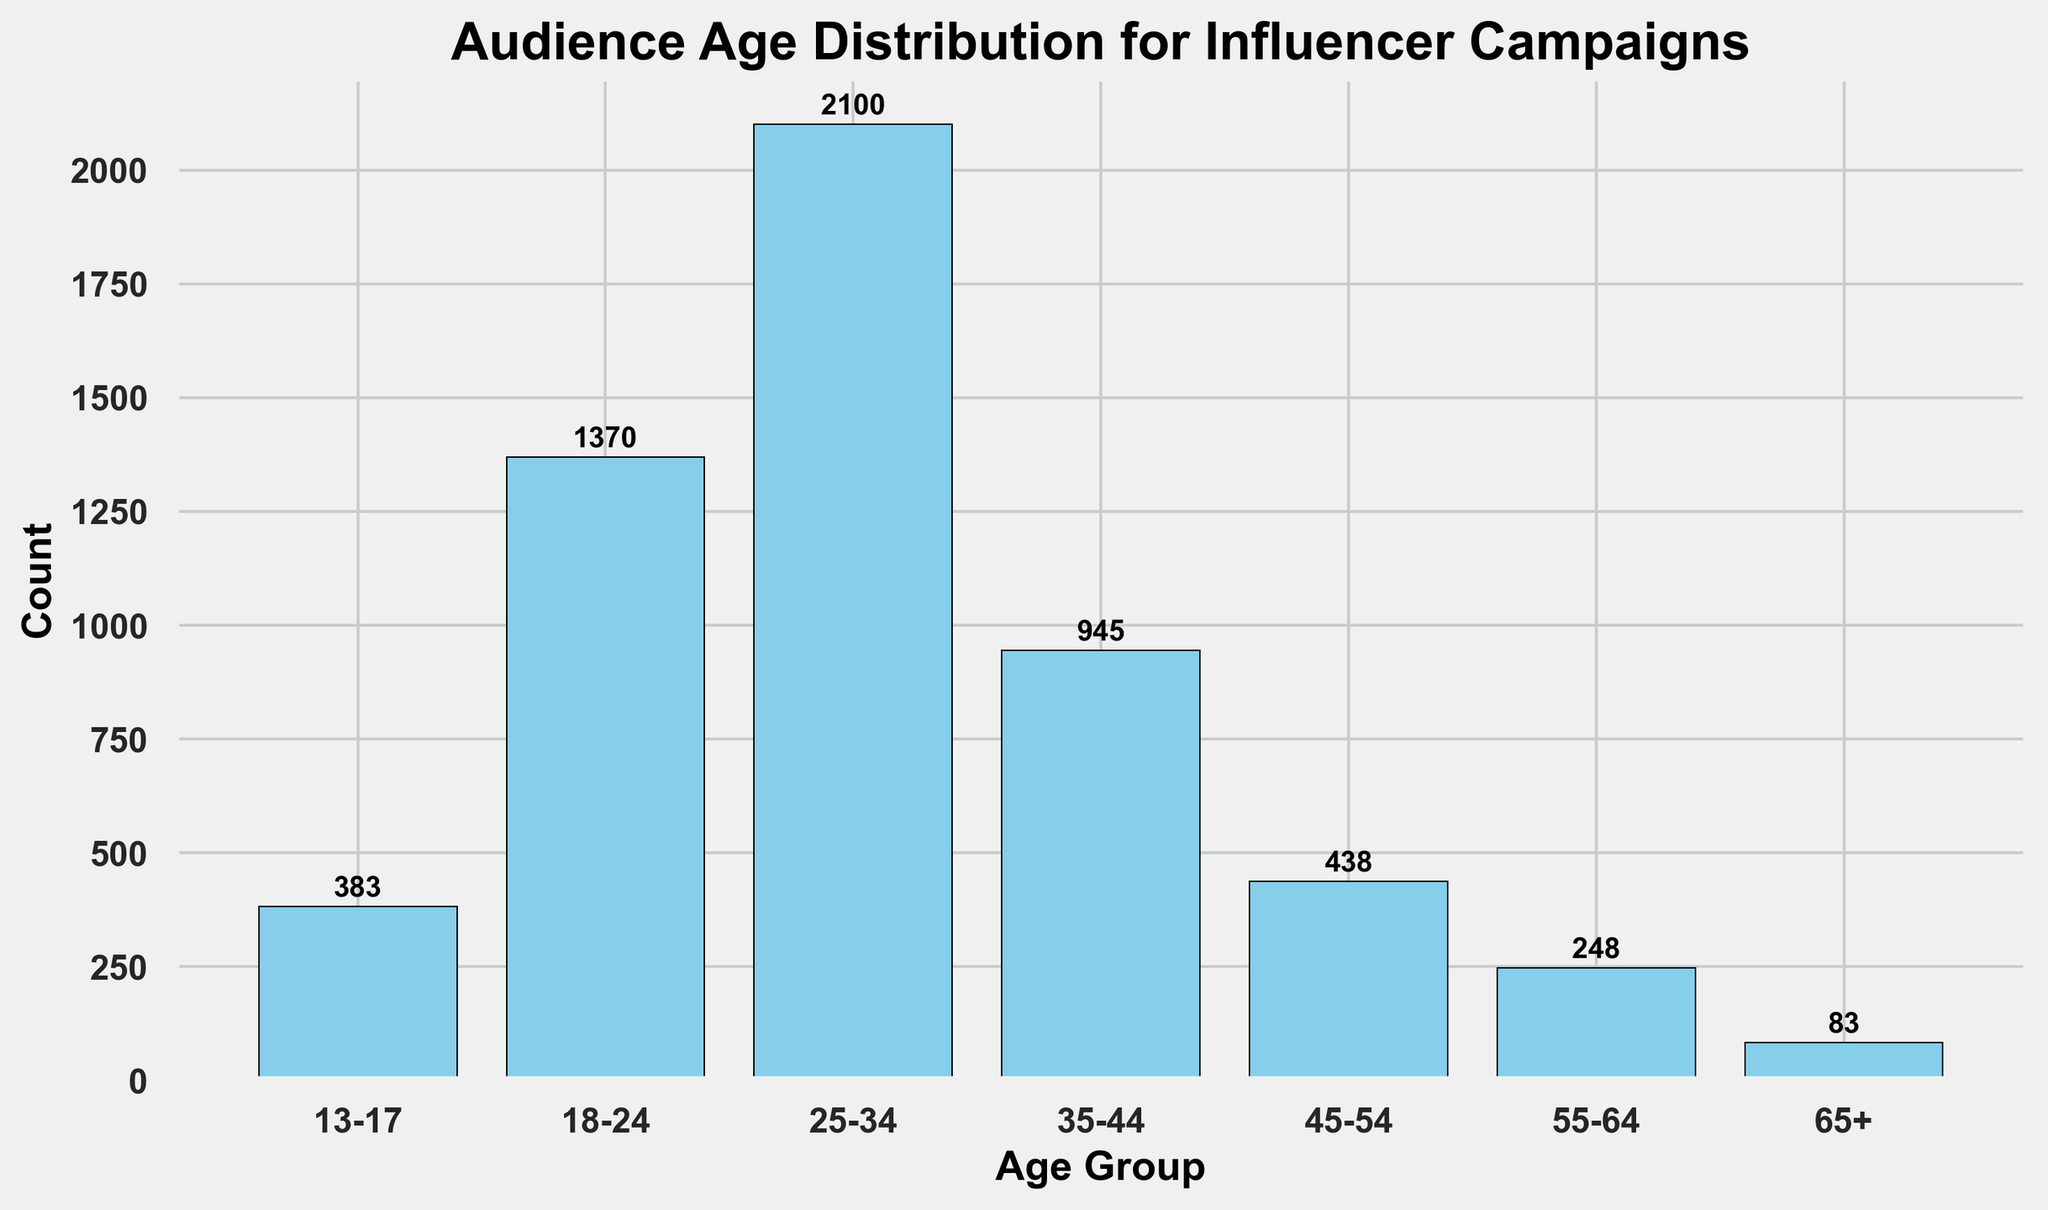Which age group has the highest count? Identify the tallest bar in the histogram and read the age group label at the base. The tallest bar represents the age group 25-34.
Answer: 25-34 What's the total count for age groups 18-24 and 25-34? Add the heights of the bars representing age groups 18-24 and 25-34. The total count is 1375 (450+465+455 + 700+690+710).
Answer: 1375 Which age group has the lowest count? Identify the shortest bar in the histogram and read the age group label at the base. The shortest bar represents the age group 65+.
Answer: 65+ How much higher is the count for age group 25-34 compared to the count for age group 35-44? Find the difference between the heights of the bars for age groups 25-34 and 35-44. The difference is 2130 - 945 = 1185.
Answer: 1185 What is the combined count for all age groups above 45? Sum the heights of the bars representing age groups 45-54, 55-64, and 65+. The total count is 150+140+148 + 80+85+83 + 25+30+28 = 769.
Answer: 769 What percentage of the total audience is in the age group 18-24? First, calculate the total count by summing all age groups (4720). Then, divide the count for 18-24 (1370) by the total count and multiply by 100. (1370/4720)*100 ≈ 29.02%.
Answer: ~29.02% Are there more audience members in the 13-17 age group or the 45-54 age group? Compare the heights of the bars for age groups 13-17 and 45-54. The combined count for 13-17 is 383 and for 45-54 is 438.
Answer: 45-54 Which two age groups have the closest counts? Compare the heights of the bars for each pair of age groups. The age groups 35-44 and 45-54 have counts closest to each other (945 vs. 438).
Answer: 35-44 and 45-54 By how much does the count decrease from the 25-34 age group to the 35-44 age group? Find the difference between the heights of the bars for age groups 25-34 and 35-44. The count decreases by 2130 - 945 = 1185.
Answer: 1185 